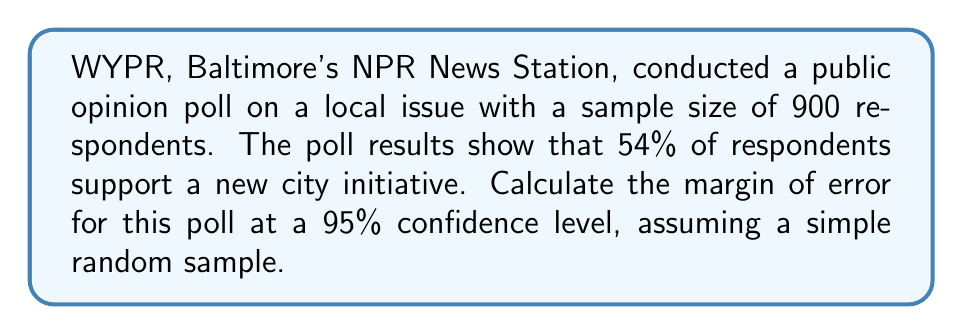Provide a solution to this math problem. To calculate the margin of error for this public opinion poll, we'll follow these steps:

1. Identify the key information:
   - Sample size (n) = 900
   - Proportion (p) = 0.54 (54% support)
   - Confidence level = 95%

2. Determine the z-score for a 95% confidence level:
   The z-score for 95% confidence is 1.96.

3. Calculate the standard error of the proportion:
   $$ SE = \sqrt{\frac{p(1-p)}{n}} $$
   $$ SE = \sqrt{\frac{0.54(1-0.54)}{900}} = \sqrt{\frac{0.2484}{900}} \approx 0.0166 $$

4. Calculate the margin of error:
   $$ \text{Margin of Error} = z \times SE $$
   $$ \text{Margin of Error} = 1.96 \times 0.0166 \approx 0.0325 $$

5. Convert to percentage:
   $$ \text{Margin of Error} = 0.0325 \times 100\% = 3.25\% $$

Thus, the margin of error for this WYPR poll is approximately 3.25%.
Answer: 3.25% 